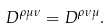Convert formula to latex. <formula><loc_0><loc_0><loc_500><loc_500>D ^ { \rho \mu \nu } = D ^ { \rho \nu \mu } .</formula> 